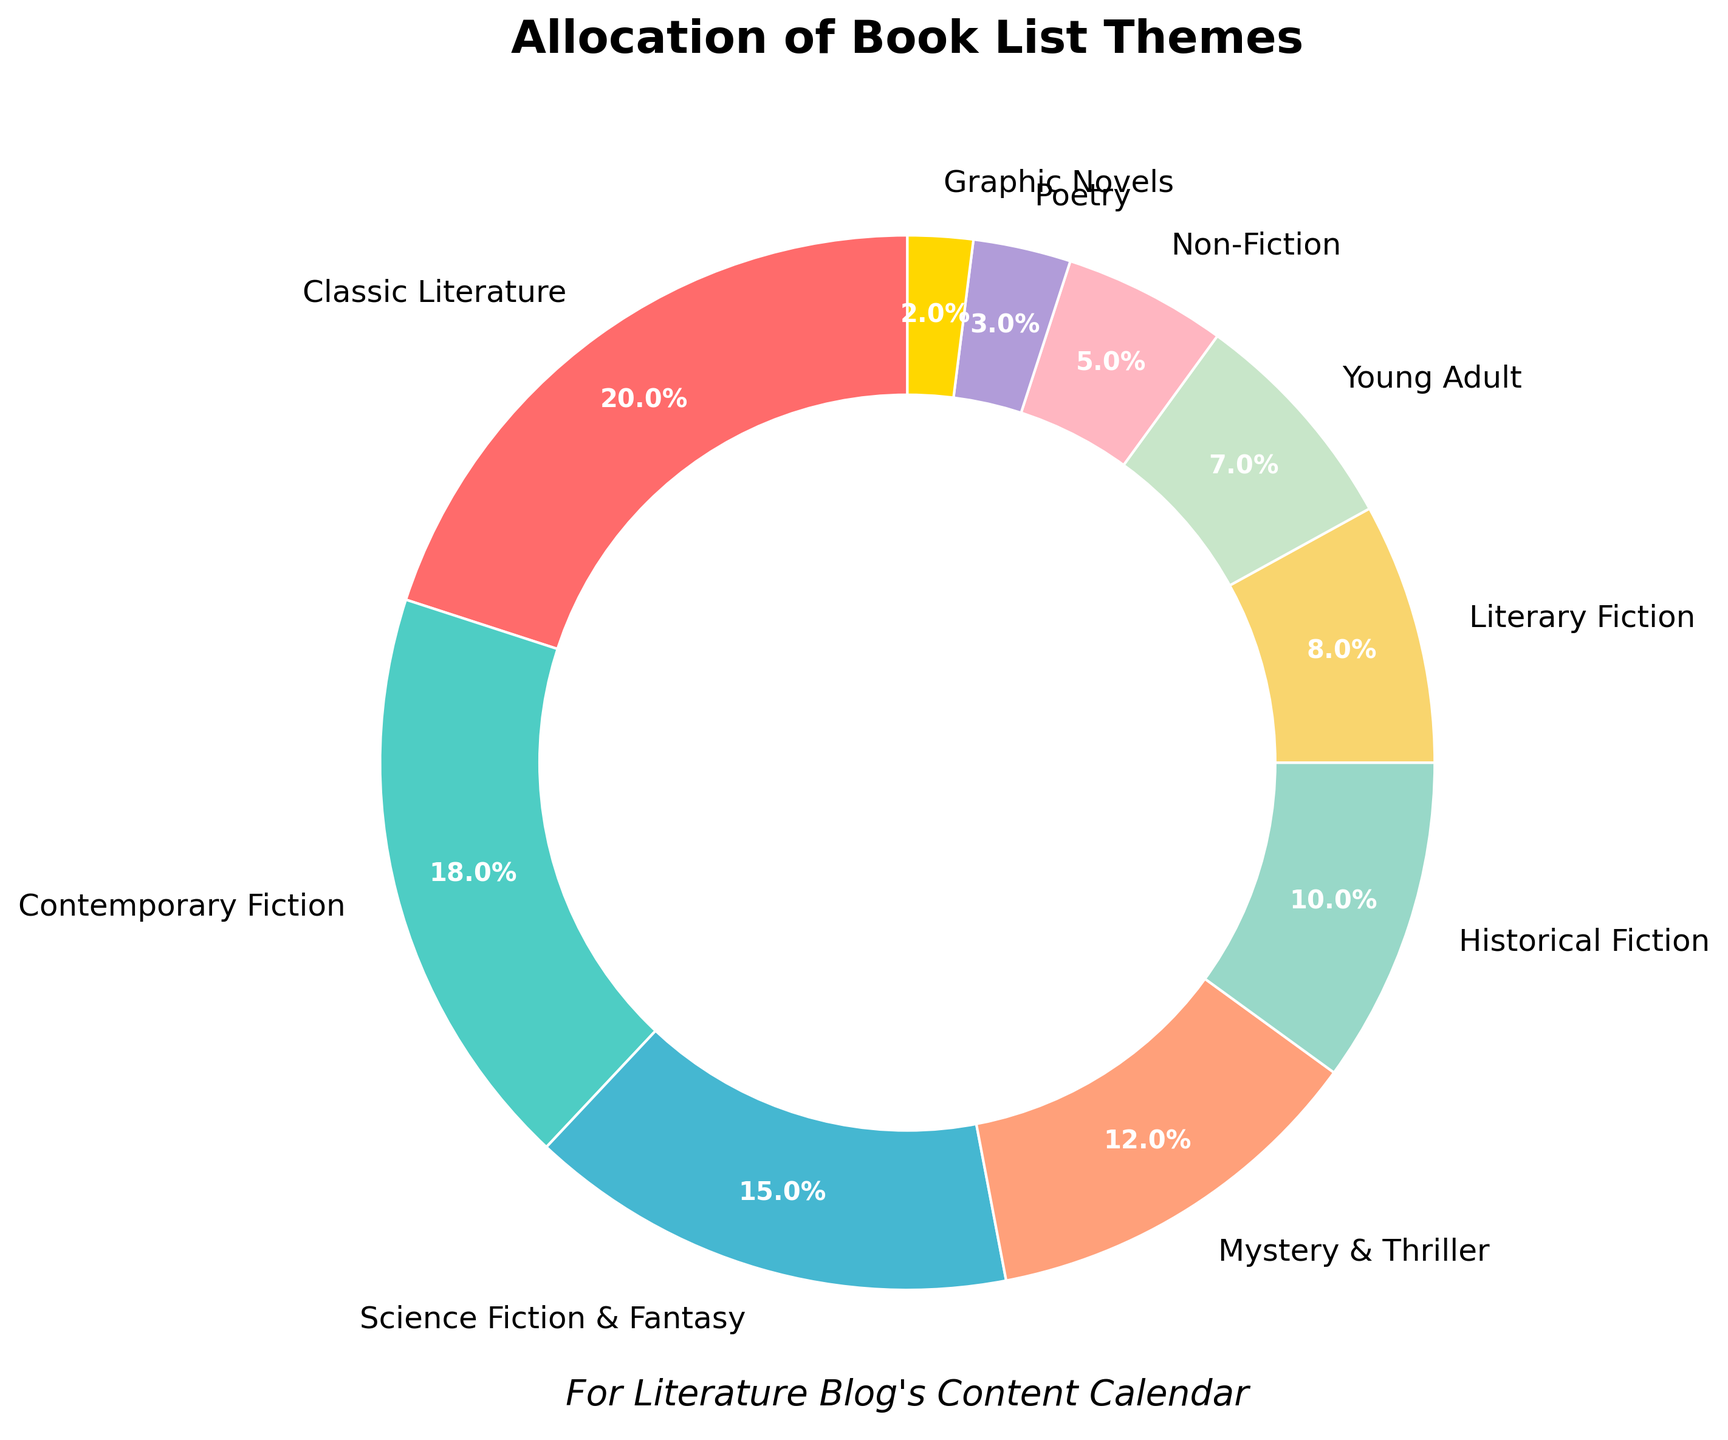What percentage of the book list themes is allocated to genres with 10% or more? To answer this, identify all genres with 10% or more and sum their percentages. These include Classic Literature (20%), Contemporary Fiction (18%), Science Fiction & Fantasy (15%), and Mystery & Thriller (12%). Sum these: 20 + 18 + 15 + 12 = 65.
Answer: 65% Which genre has the smallest allocation, and what is its percentage? Look for the genre with the lowest percentage on the pie chart, which is Graphic Novels at 2%.
Answer: Graphic Novels, 2% How much more percentage does Classic Literature have compared to Young Adult? Subtract the percentage of Young Adult (7%) from Classic Literature (20%). So, 20 - 7 = 13.
Answer: 13% What is the combined percentage of Literary Fiction and Non-Fiction? Add the percentages of Literary Fiction (8%) and Non-Fiction (5%). So, 8 + 5 = 13.
Answer: 13% Which theme has a larger percentage, Science Fiction & Fantasy or Historical Fiction, and by how much? Find the difference between their percentages: Science Fiction & Fantasy (15%) and Historical Fiction (10%). So, 15 - 10 = 5.
Answer: Science Fiction & Fantasy, 5% List all genres that have an allocation greater than or equal to 10% but less than 20%. Identify genres within this range: Contemporary Fiction (18%), Science Fiction & Fantasy (15%), Mystery & Thriller (12%), and Historical Fiction (10%).
Answer: Contemporary Fiction, Science Fiction & Fantasy, Mystery & Thriller, Historical Fiction If you combine the percentages of Poetry, Graphic Novels, and Young Adult, what percentage of the content calendar do they represent? Add their percentages: Poetry (3%), Graphic Novels (2%), and Young Adult (7%). So, 3 + 2 + 7 = 12.
Answer: 12% What color represents the Non-Fiction theme in the pie chart? Identify the Non-Fiction slice on the pie chart, which is visually distinct with a specific color, in this case, pale pink.
Answer: Pale pink Among the themes Classic Literature, Contemporary Fiction, and Science Fiction & Fantasy, which one has the highest percentage and what is the difference in percentage between the highest and the lowest? The highest is Classic Literature at 20%, and the lowest among the three is Science Fiction & Fantasy at 15%. The difference is 20 - 15 = 5.
Answer: Classic Literature, 5% What is the average percentage allocation for the genres Classic Literature, Mystery & Thriller, and Young Adult? Find the average by summing their percentages and dividing by the number of genres: (20 + 12 + 7) / 3 = 13.
Answer: 13 